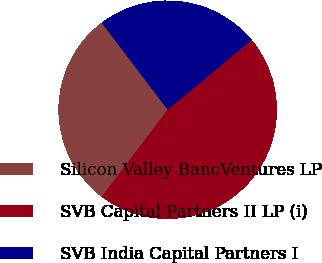Convert chart to OTSL. <chart><loc_0><loc_0><loc_500><loc_500><pie_chart><fcel>Silicon Valley BancVentures LP<fcel>SVB Capital Partners II LP (i)<fcel>SVB India Capital Partners I<nl><fcel>29.34%<fcel>46.38%<fcel>24.29%<nl></chart> 